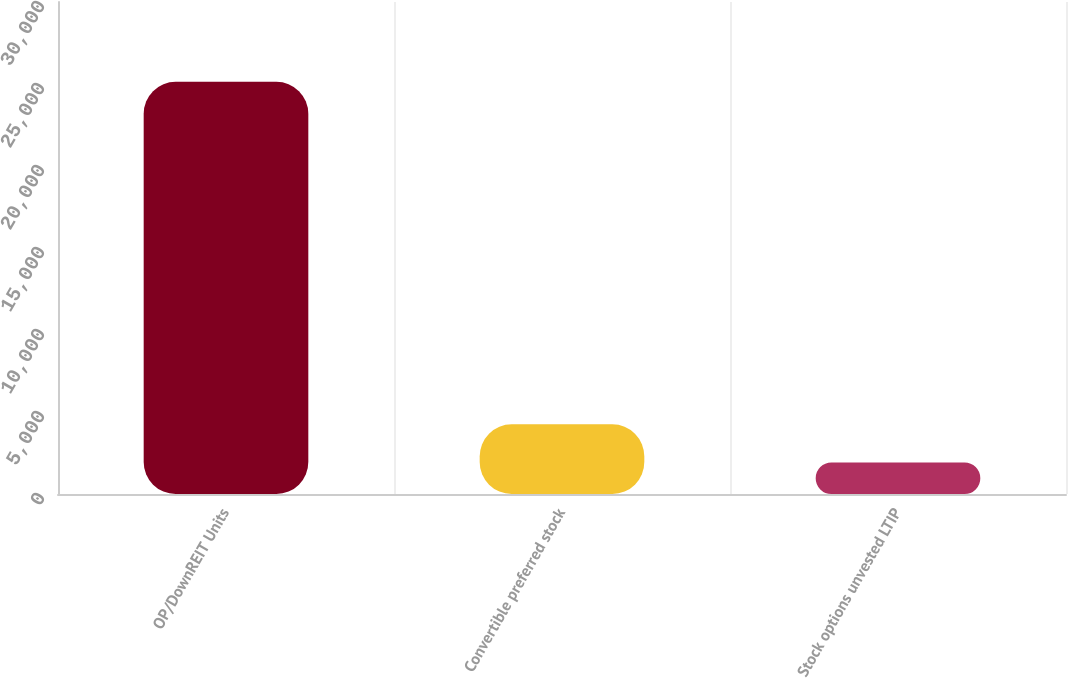Convert chart. <chart><loc_0><loc_0><loc_500><loc_500><bar_chart><fcel>OP/DownREIT Units<fcel>Convertible preferred stock<fcel>Stock options unvested LTIP<nl><fcel>25130<fcel>4245.5<fcel>1925<nl></chart> 